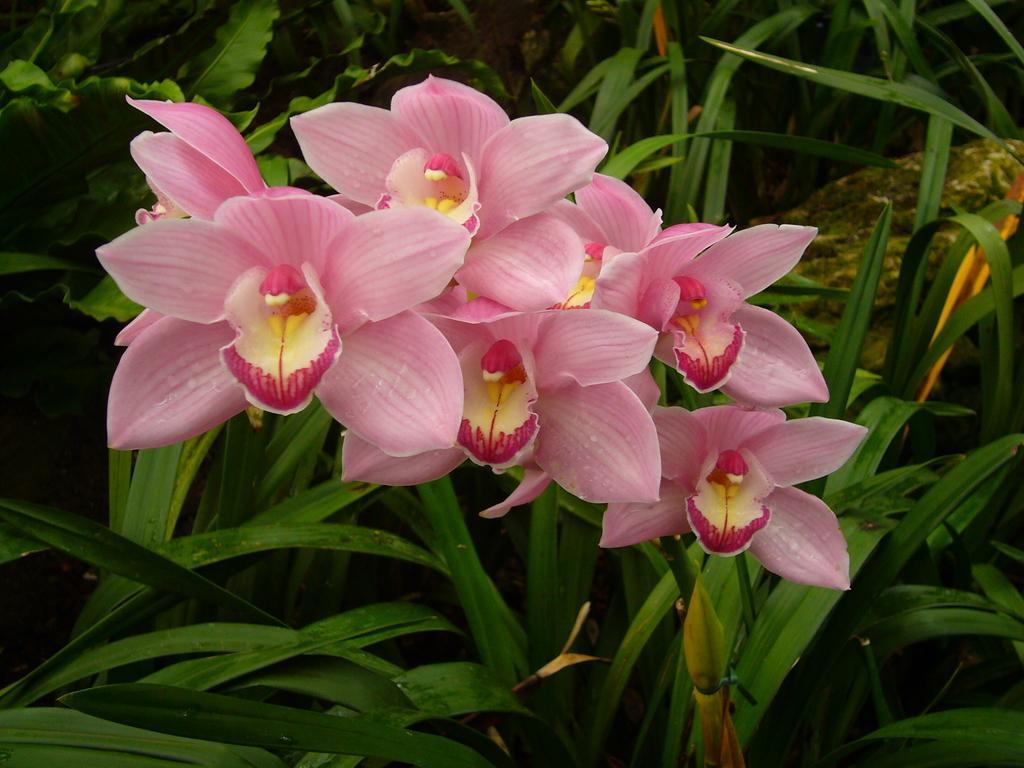Can you describe this image briefly? In this picture we can see a few pink flowers on a plant. 